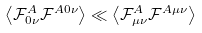<formula> <loc_0><loc_0><loc_500><loc_500>\left \langle \mathcal { F } ^ { A } _ { 0 \nu } \mathcal { F } ^ { A 0 \nu } \right \rangle \ll \left \langle \mathcal { F } ^ { A } _ { \mu \nu } \mathcal { F } ^ { A \mu \nu } \right \rangle</formula> 